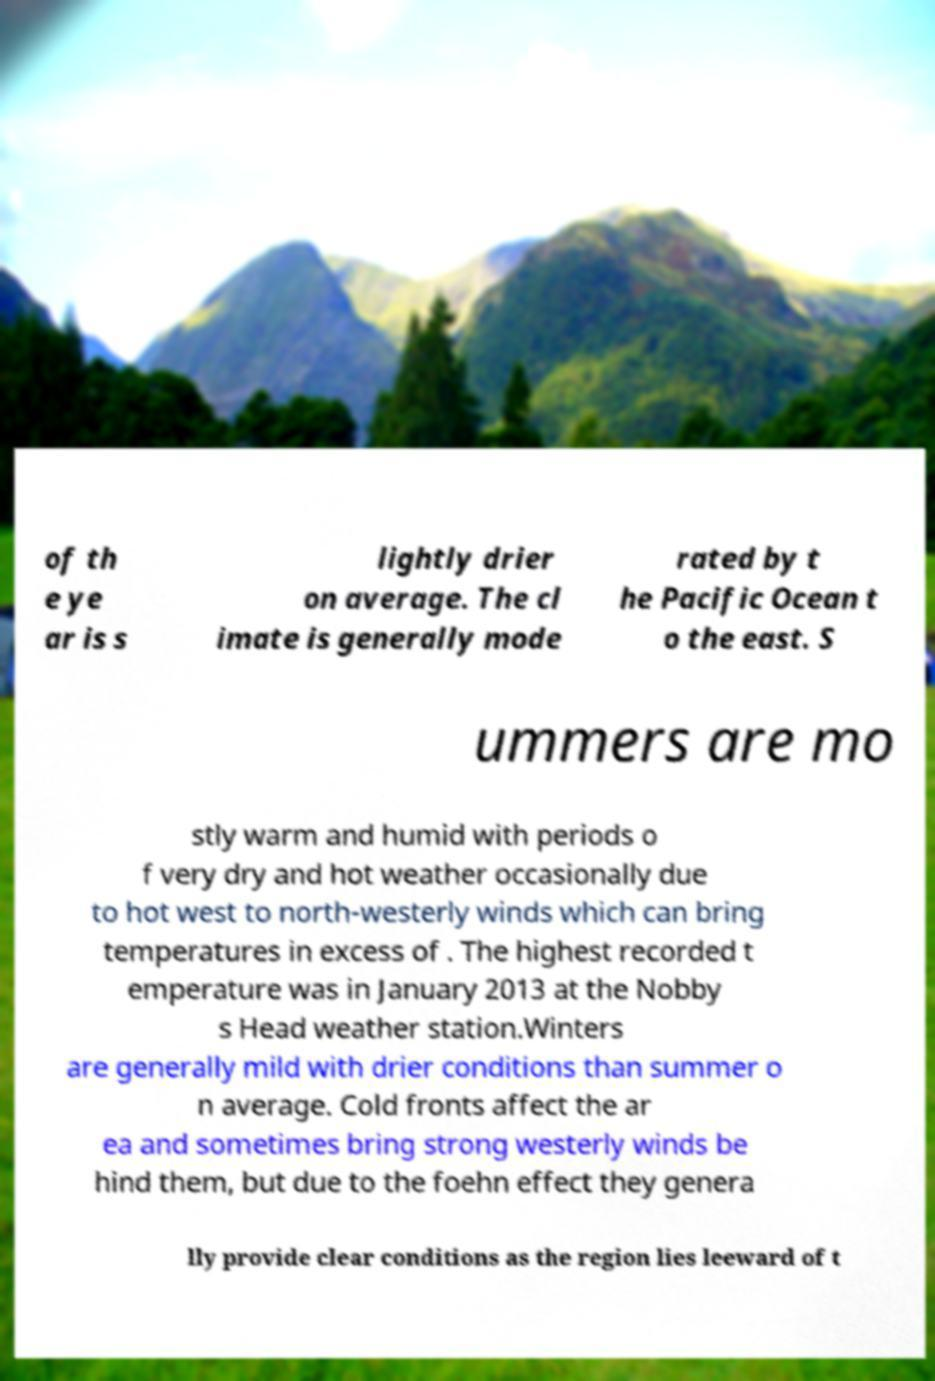For documentation purposes, I need the text within this image transcribed. Could you provide that? of th e ye ar is s lightly drier on average. The cl imate is generally mode rated by t he Pacific Ocean t o the east. S ummers are mo stly warm and humid with periods o f very dry and hot weather occasionally due to hot west to north-westerly winds which can bring temperatures in excess of . The highest recorded t emperature was in January 2013 at the Nobby s Head weather station.Winters are generally mild with drier conditions than summer o n average. Cold fronts affect the ar ea and sometimes bring strong westerly winds be hind them, but due to the foehn effect they genera lly provide clear conditions as the region lies leeward of t 